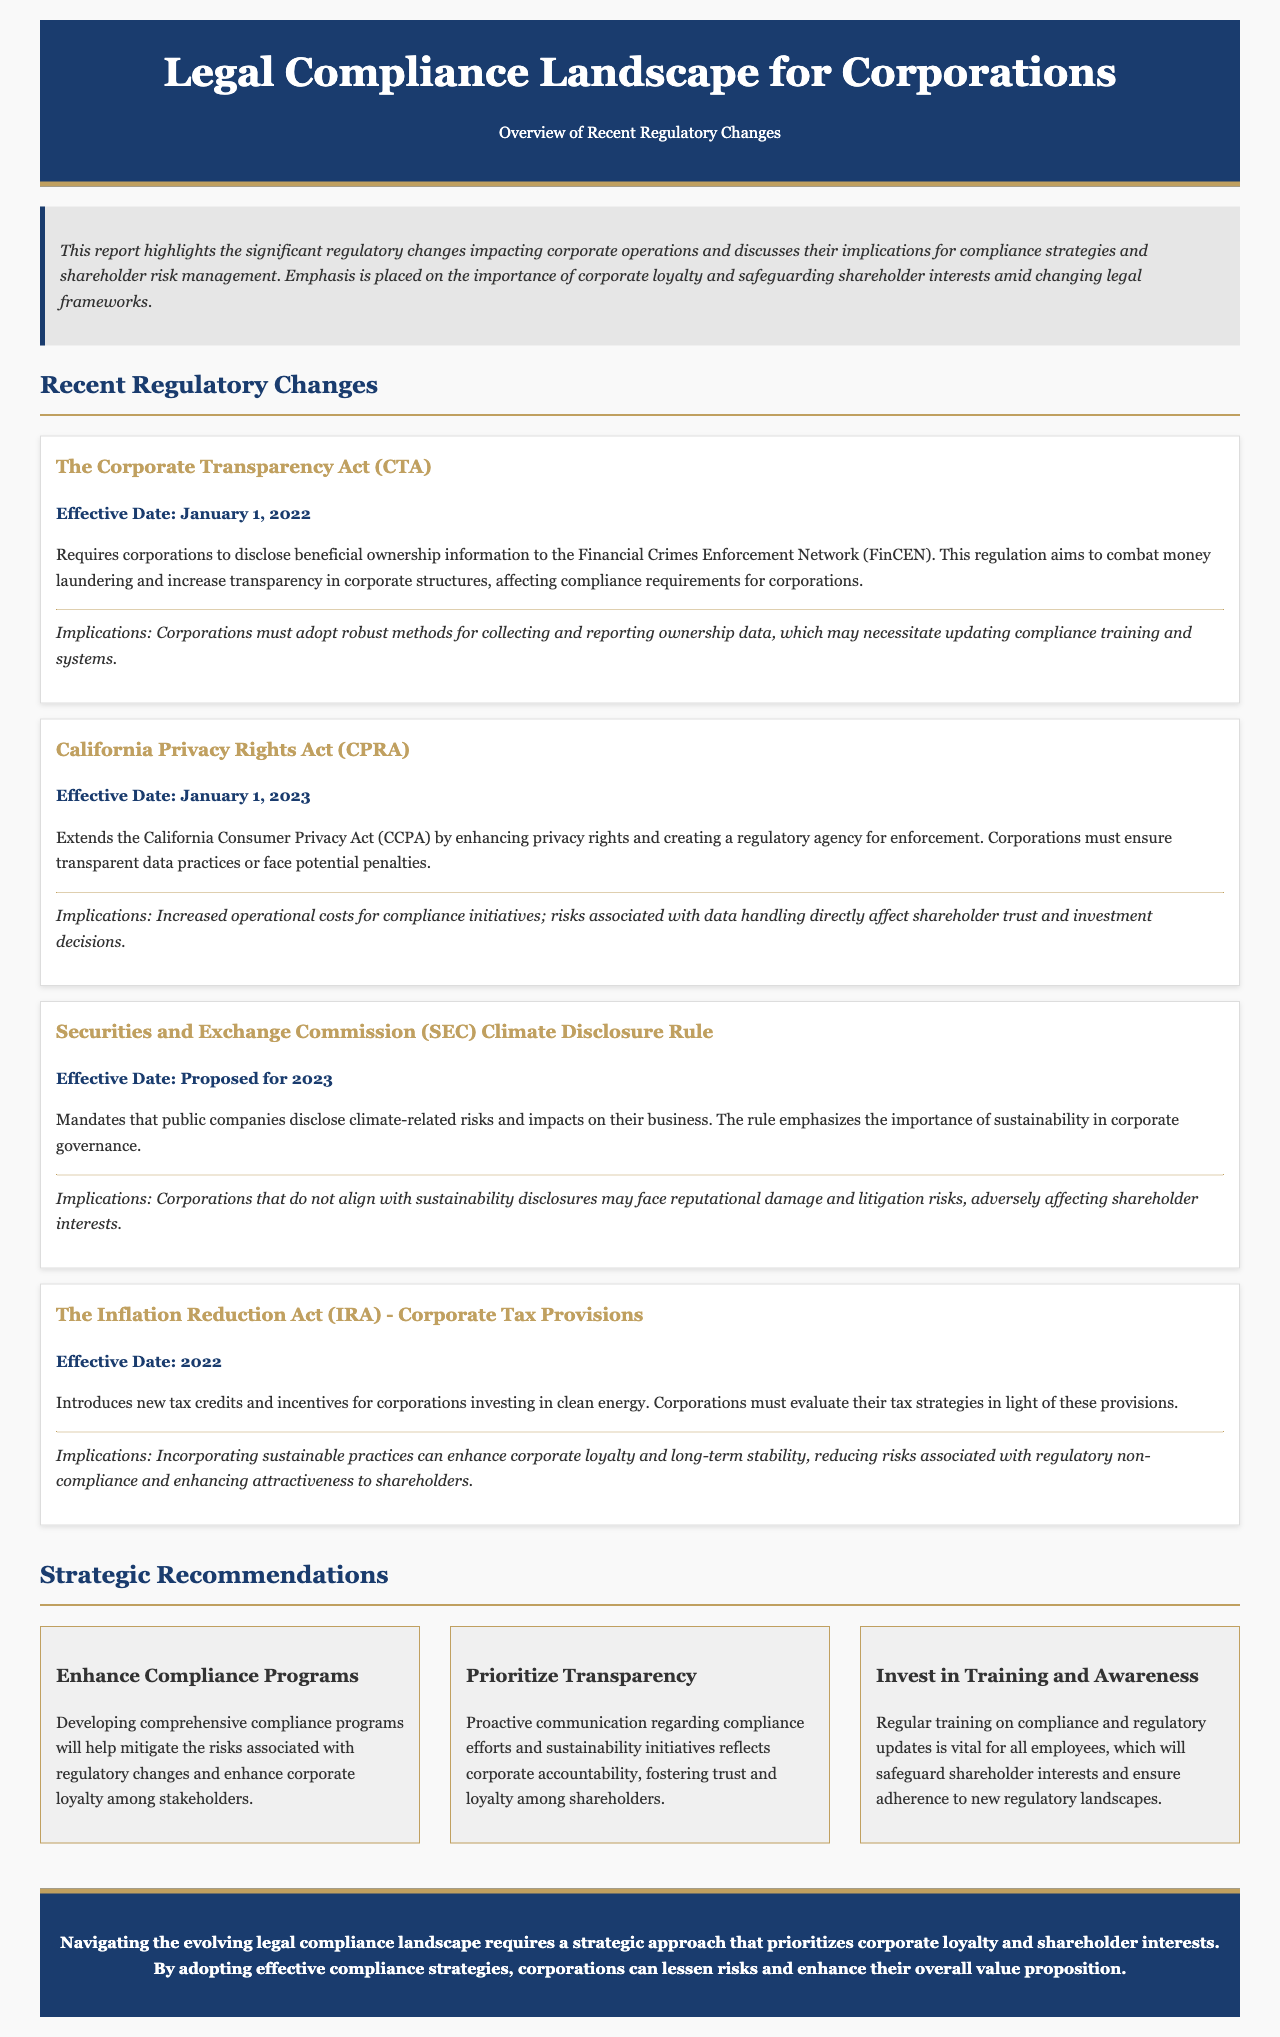What is the effective date of the Corporate Transparency Act? The effective date is mentioned under this regulation as January 1, 2022.
Answer: January 1, 2022 What does the California Privacy Rights Act (CPRA) enhance? The CPRA enhances privacy rights and creates a regulatory agency for enforcement, as stated in the document.
Answer: Privacy rights What is a primary implication of the SEC Climate Disclosure Rule? The primary implication discussed is reputational damage and litigation risks if corporations do not align with sustainability disclosures.
Answer: Reputational damage When was the Inflation Reduction Act's corporate tax provisions effective? The date is provided in the document as 2022.
Answer: 2022 What is one recommendation to safeguard shareholder interests? The recommendation mentioned focuses on regular training on compliance and regulatory updates for employees.
Answer: Invest in Training and Awareness What does the executive summary emphasize regarding corporate behavior? It emphasizes the importance of corporate loyalty and safeguarding shareholder interests amid changing legal frameworks.
Answer: Corporate loyalty What is required by the Corporate Transparency Act? The act requires corporations to disclose beneficial ownership information to the Financial Crimes Enforcement Network (FinCEN).
Answer: Disclosure of beneficial ownership information What is the main focus of the report? The report highlights significant regulatory changes and their implications on compliance strategies and shareholder risk management.
Answer: Recent regulatory changes What should corporations adopt to mitigate risks associated with regulatory changes? Corporations should adopt comprehensive compliance programs, as recommended in the document.
Answer: Enhance Compliance Programs 